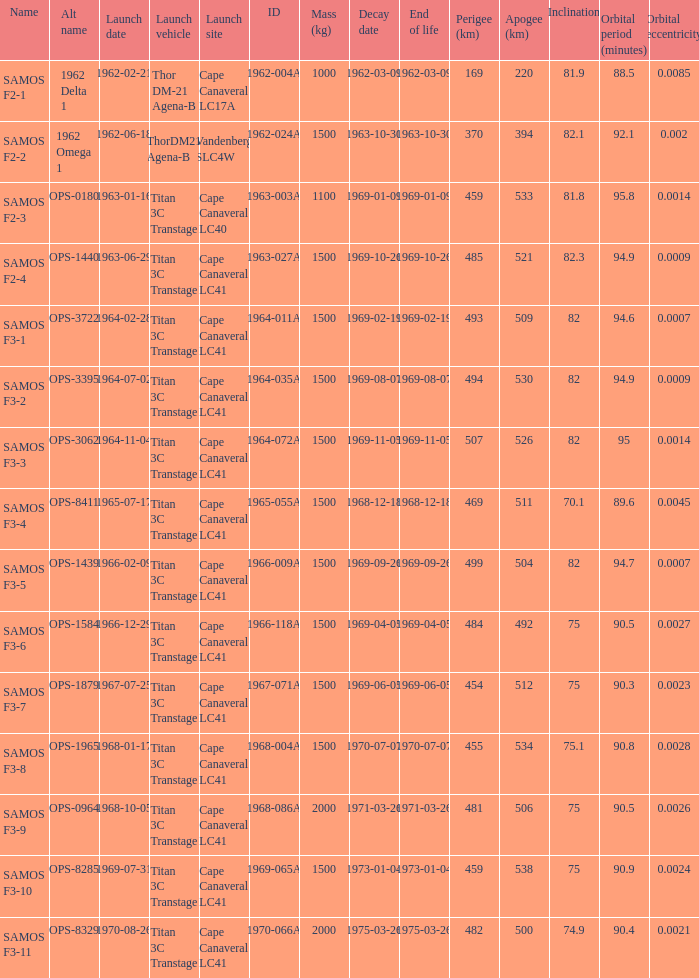What was the highest perigee on 1969-01-09? 459.0. 